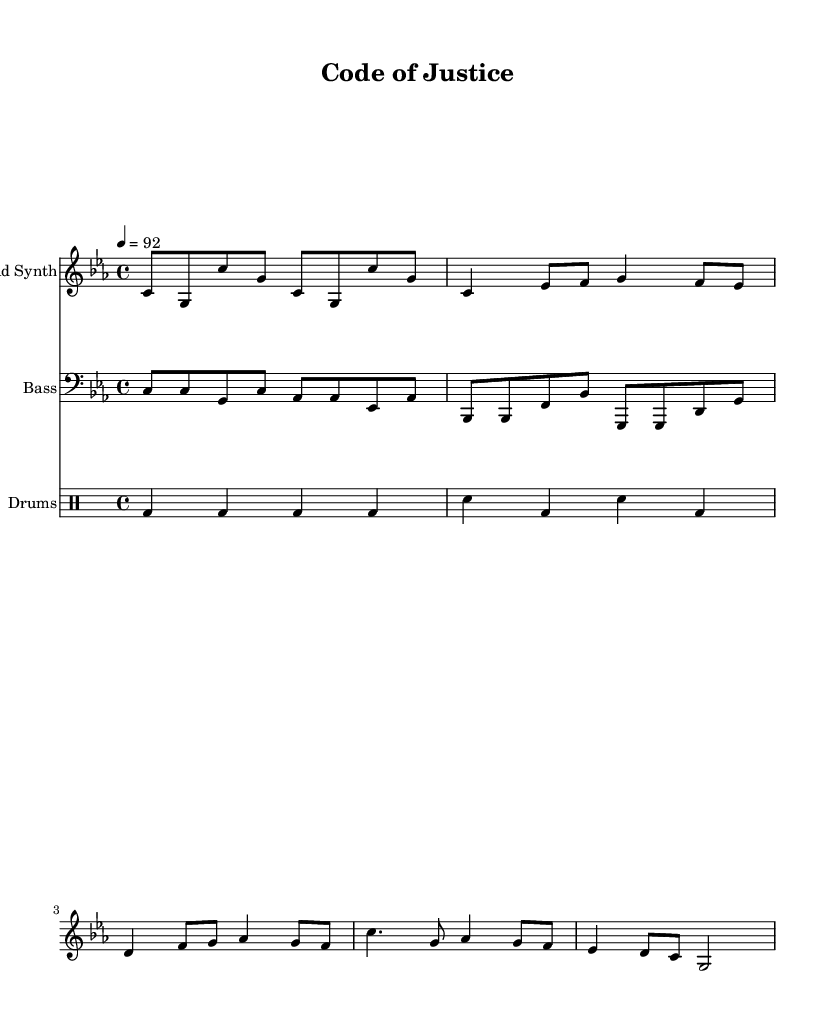What is the key signature of this music? The key signature is C minor, which has three flats: B flat, E flat, and A flat. This can be identified by looking at the beginning of the staff where the flats are indicated.
Answer: C minor What is the time signature of the piece? The time signature is 4/4, which means there are four beats in a measure and a quarter note gets one beat. This can be seen at the beginning of the music where the time signature is noted.
Answer: 4/4 What is the tempo marking for this piece? The tempo is marked at 92 beats per minute, indicated by the "4 = 92" at the start of the score. This tells us the speed at which to perform the piece.
Answer: 92 How many measures are in the verse section? The verse section contains three measures, which can be counted by looking at the grouped notation of the lead synth part section that corresponds to the verse.
Answer: 3 In which instrument is the melody primarily found? The melody is primarily in the lead synth, as indicated by its name on the staff. The lead synth part features the main melodic content that carries the theme of the piece.
Answer: Lead Synth What rhythmic pattern is presented in the drum section? The drum section features a repeated pattern of bass drums on each beat and snare drums on the second and fourth beats, which can be observed by examining the drummode notation closely.
Answer: Four-on-the-floor How does the structure of this rap music compare to traditional song forms? The structure follows a standard verse-chorus pattern typical in rap music, which contrasts with traditional forms that may include bridge or refrain sections; this structure can be seen by observing the arrangement of the verses and chorus in the lead synth part.
Answer: Verse-chorus 